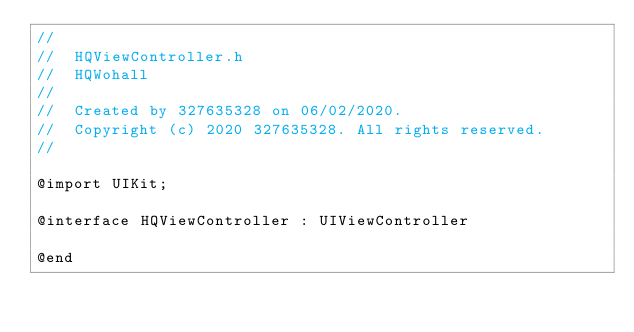<code> <loc_0><loc_0><loc_500><loc_500><_C_>//
//  HQViewController.h
//  HQWohall
//
//  Created by 327635328 on 06/02/2020.
//  Copyright (c) 2020 327635328. All rights reserved.
//

@import UIKit;

@interface HQViewController : UIViewController

@end
</code> 